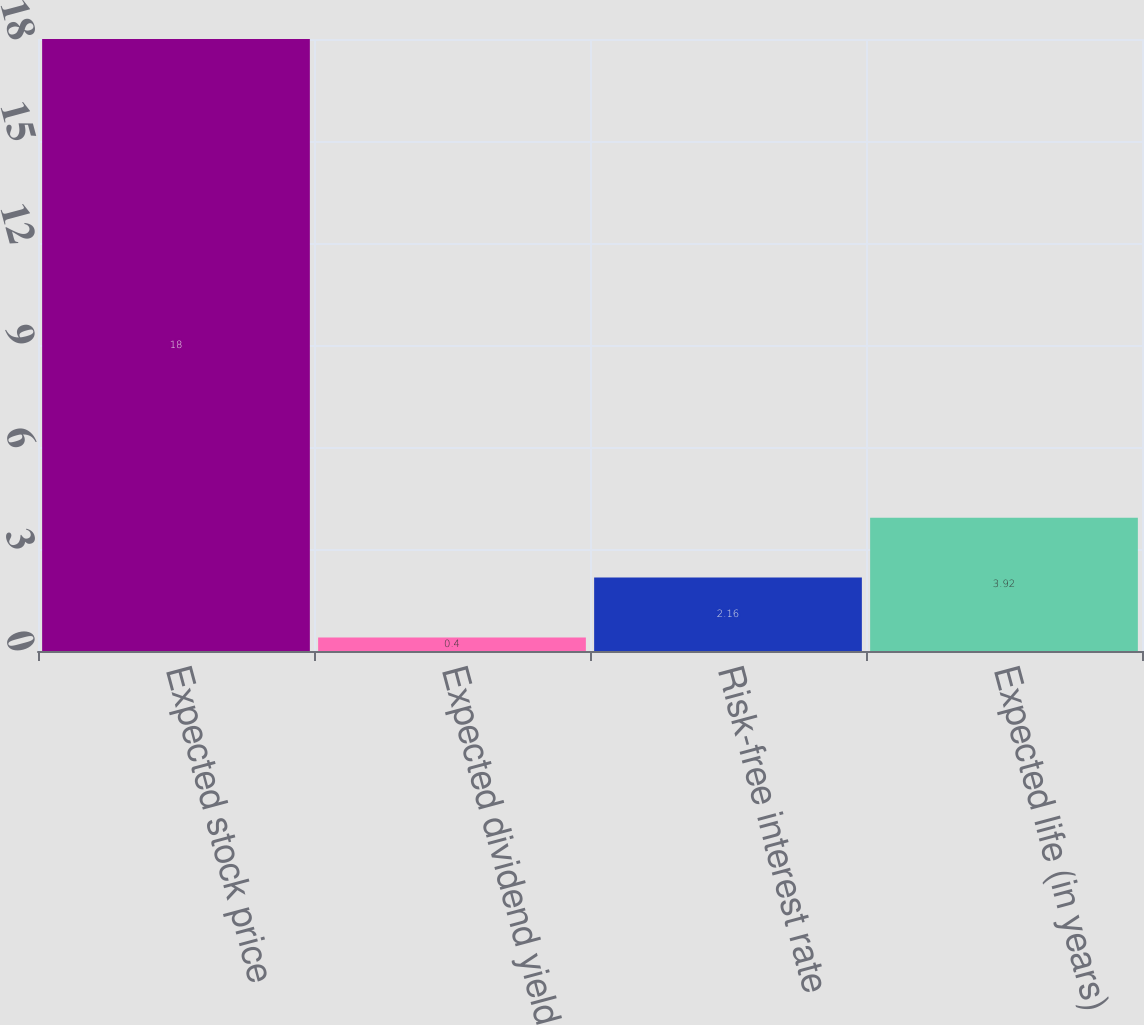Convert chart. <chart><loc_0><loc_0><loc_500><loc_500><bar_chart><fcel>Expected stock price<fcel>Expected dividend yield<fcel>Risk-free interest rate<fcel>Expected life (in years)<nl><fcel>18<fcel>0.4<fcel>2.16<fcel>3.92<nl></chart> 